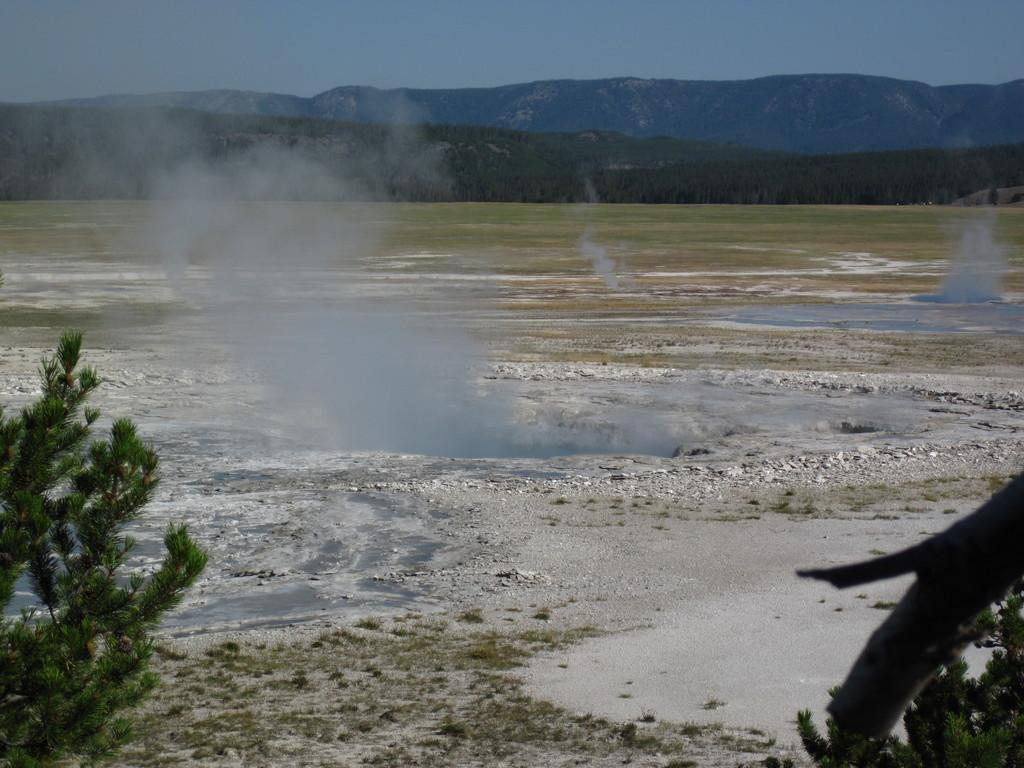What celestial bodies are present in the image? There are planets in the image. What type of natural features can be seen in the image? There are trees and mountains in the image. What is visible in the background of the image? The sky is visible in the background of the image. What type of lettuce is growing on the mountains in the image? There is no lettuce present in the image; the image features planets, trees, mountains, and the sky. 